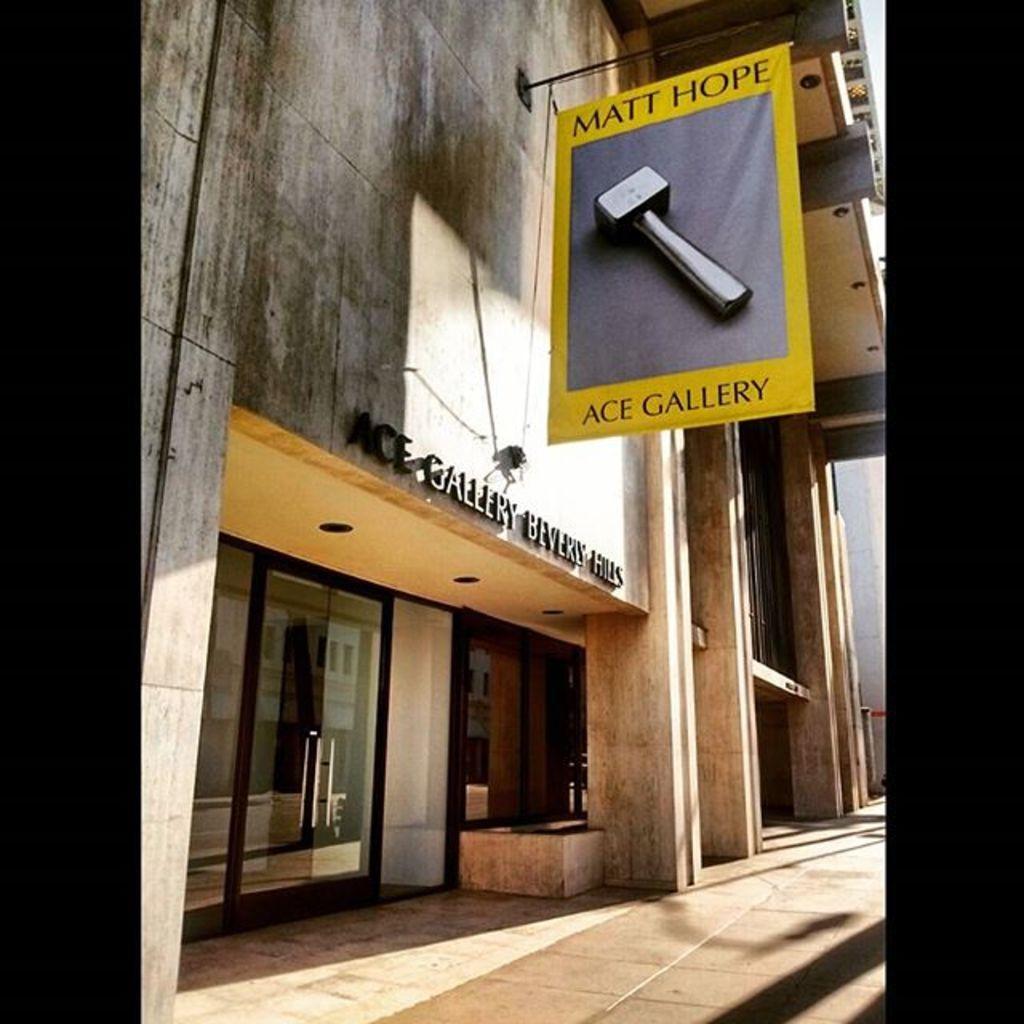In one or two sentences, can you explain what this image depicts? In this picture there is a building to which there is a poster of yellow color and ground floor there is a glass door and something written on the top. 